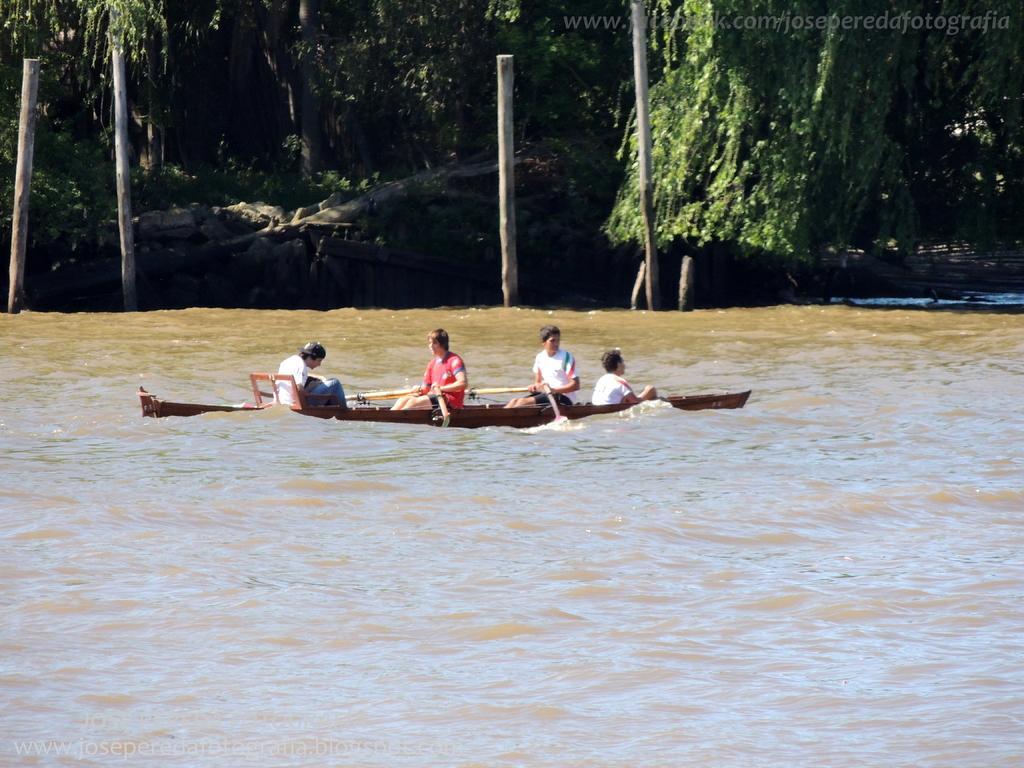Please provide a concise description of this image. In this image we can see water, boat, people, wooden logs, trees and watermark. 